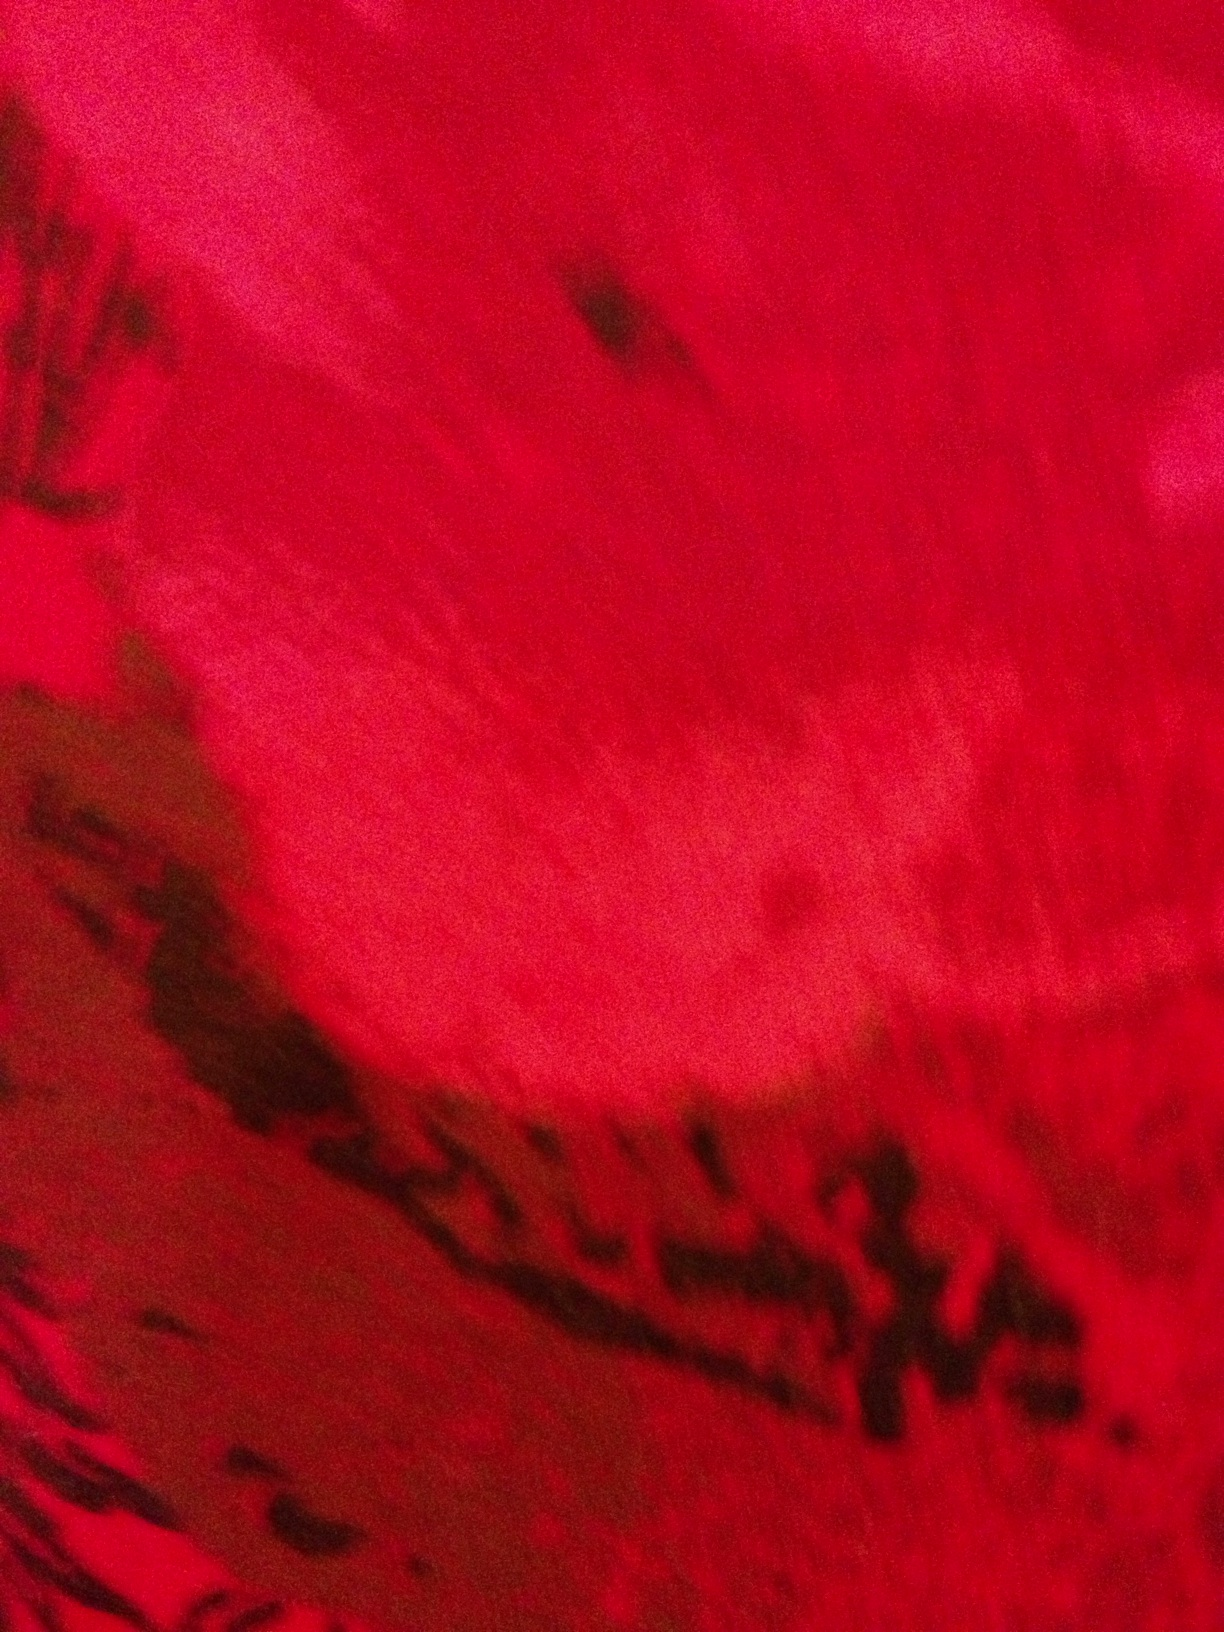What does this look like? The image depicts a vibrant close-up of a red, textured surface. It seems to represent either a natural object, such as a flower petal, or an artistic creation, like an abstract painting. The various shades of red, combined with darker mottled patches and variations in texture, give the surface a lively and dynamic appearance, almost inviting one to reach out and touch it. 